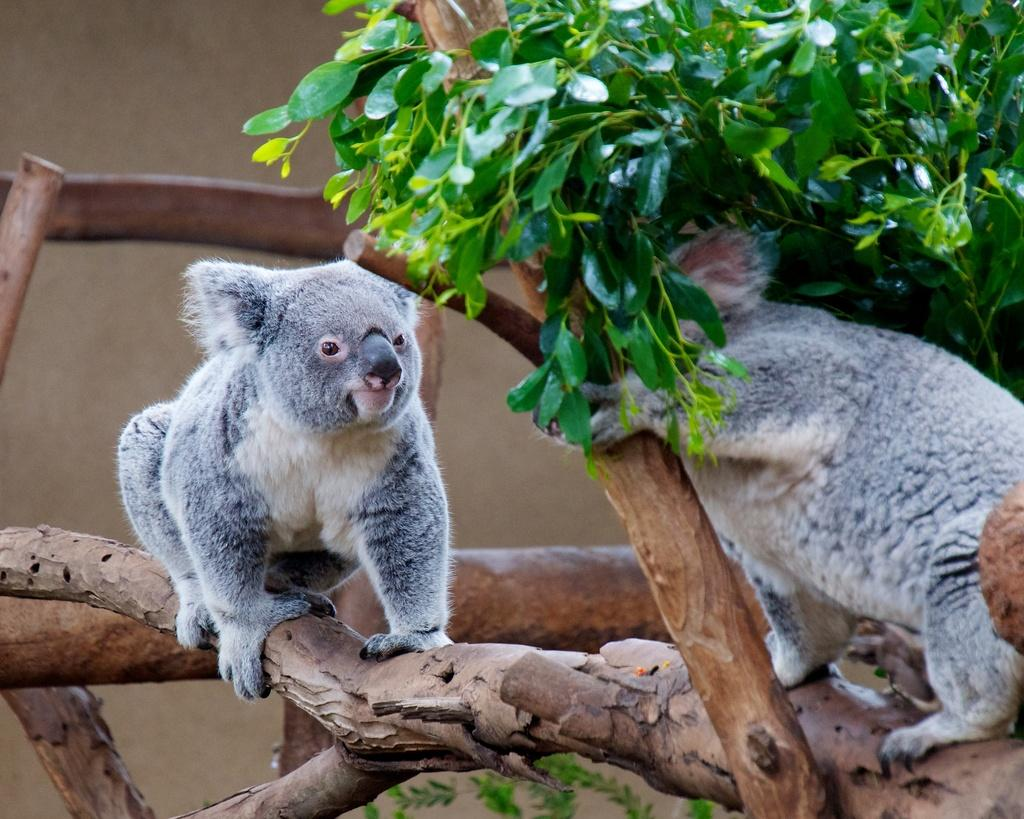What types of animals are in the middle of the image? There are two animals in the middle of the image. What else can be seen in the image besides the animals? There are branches of a tree in the image. What type of vegetation is on the right side of the image? There are green leaves on the right side of the image. What type of oven can be seen in the image? There is no oven present in the image. 